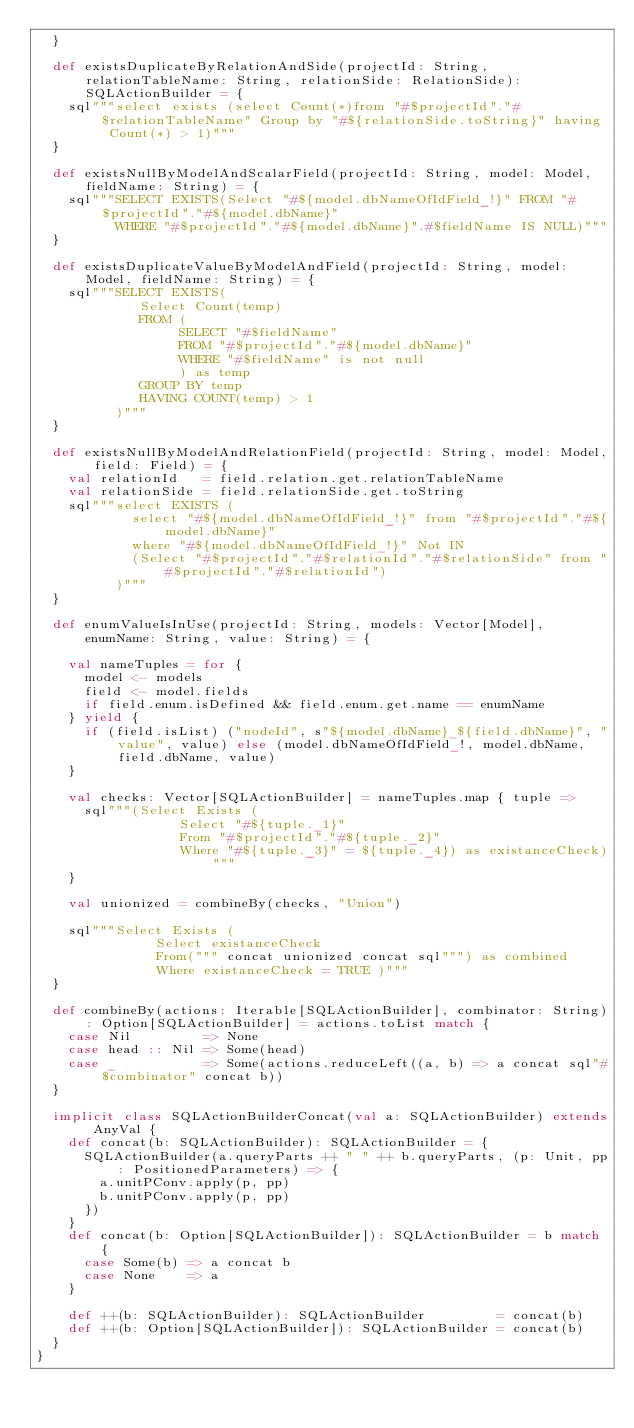<code> <loc_0><loc_0><loc_500><loc_500><_Scala_>  }

  def existsDuplicateByRelationAndSide(projectId: String, relationTableName: String, relationSide: RelationSide): SQLActionBuilder = {
    sql"""select exists (select Count(*)from "#$projectId"."#$relationTableName" Group by "#${relationSide.toString}" having Count(*) > 1)"""
  }

  def existsNullByModelAndScalarField(projectId: String, model: Model, fieldName: String) = {
    sql"""SELECT EXISTS(Select "#${model.dbNameOfIdField_!}" FROM "#$projectId"."#${model.dbName}"
          WHERE "#$projectId"."#${model.dbName}".#$fieldName IS NULL)"""
  }

  def existsDuplicateValueByModelAndField(projectId: String, model: Model, fieldName: String) = {
    sql"""SELECT EXISTS(
             Select Count(temp)
             FROM (
                  SELECT "#$fieldName"
                  FROM "#$projectId"."#${model.dbName}"
                  WHERE "#$fieldName" is not null
                  ) as temp
             GROUP BY temp
             HAVING COUNT(temp) > 1
          )"""
  }

  def existsNullByModelAndRelationField(projectId: String, model: Model, field: Field) = {
    val relationId   = field.relation.get.relationTableName
    val relationSide = field.relationSide.get.toString
    sql"""select EXISTS (
            select "#${model.dbNameOfIdField_!}" from "#$projectId"."#${model.dbName}"
            where "#${model.dbNameOfIdField_!}" Not IN
            (Select "#$projectId"."#$relationId"."#$relationSide" from "#$projectId"."#$relationId")
          )"""
  }

  def enumValueIsInUse(projectId: String, models: Vector[Model], enumName: String, value: String) = {

    val nameTuples = for {
      model <- models
      field <- model.fields
      if field.enum.isDefined && field.enum.get.name == enumName
    } yield {
      if (field.isList) ("nodeId", s"${model.dbName}_${field.dbName}", "value", value) else (model.dbNameOfIdField_!, model.dbName, field.dbName, value)
    }

    val checks: Vector[SQLActionBuilder] = nameTuples.map { tuple =>
      sql"""(Select Exists (
                  Select "#${tuple._1}"
                  From "#$projectId"."#${tuple._2}"
                  Where "#${tuple._3}" = ${tuple._4}) as existanceCheck)"""
    }

    val unionized = combineBy(checks, "Union")

    sql"""Select Exists (
               Select existanceCheck
               From(""" concat unionized concat sql""") as combined
               Where existanceCheck = TRUE )"""
  }

  def combineBy(actions: Iterable[SQLActionBuilder], combinator: String): Option[SQLActionBuilder] = actions.toList match {
    case Nil         => None
    case head :: Nil => Some(head)
    case _           => Some(actions.reduceLeft((a, b) => a concat sql"#$combinator" concat b))
  }

  implicit class SQLActionBuilderConcat(val a: SQLActionBuilder) extends AnyVal {
    def concat(b: SQLActionBuilder): SQLActionBuilder = {
      SQLActionBuilder(a.queryParts ++ " " ++ b.queryParts, (p: Unit, pp: PositionedParameters) => {
        a.unitPConv.apply(p, pp)
        b.unitPConv.apply(p, pp)
      })
    }
    def concat(b: Option[SQLActionBuilder]): SQLActionBuilder = b match {
      case Some(b) => a concat b
      case None    => a
    }

    def ++(b: SQLActionBuilder): SQLActionBuilder         = concat(b)
    def ++(b: Option[SQLActionBuilder]): SQLActionBuilder = concat(b)
  }
}
</code> 